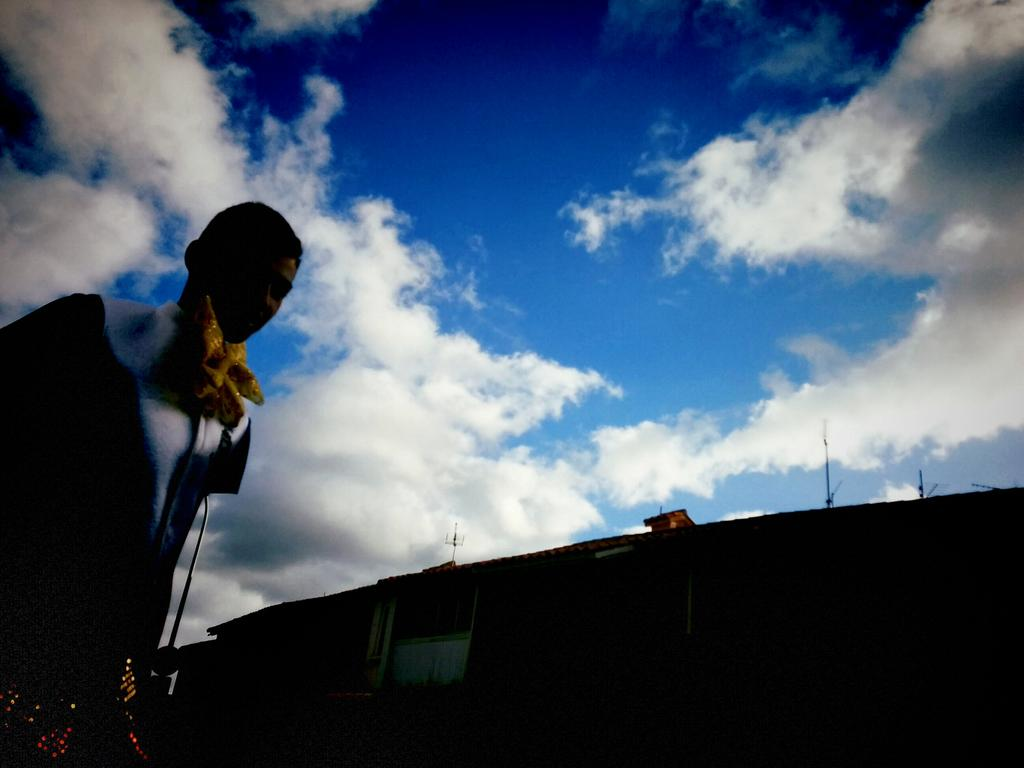What is located on the left side of the image? There is a person standing on the left side of the image. What type of structure can be seen in the image? There is a house in the image. Where is the house situated in relation to the image? The house is located at the bottom of the image. What is visible in the image besides the person and the house? The sky is visible in the image. How would you describe the sky in the image? The sky appears to be cloudy. How many children are wearing dresses in the image? There are no children or dresses present in the image. What is the person trying to balance in the image? There is no indication of the person attempting to balance anything in the image. 